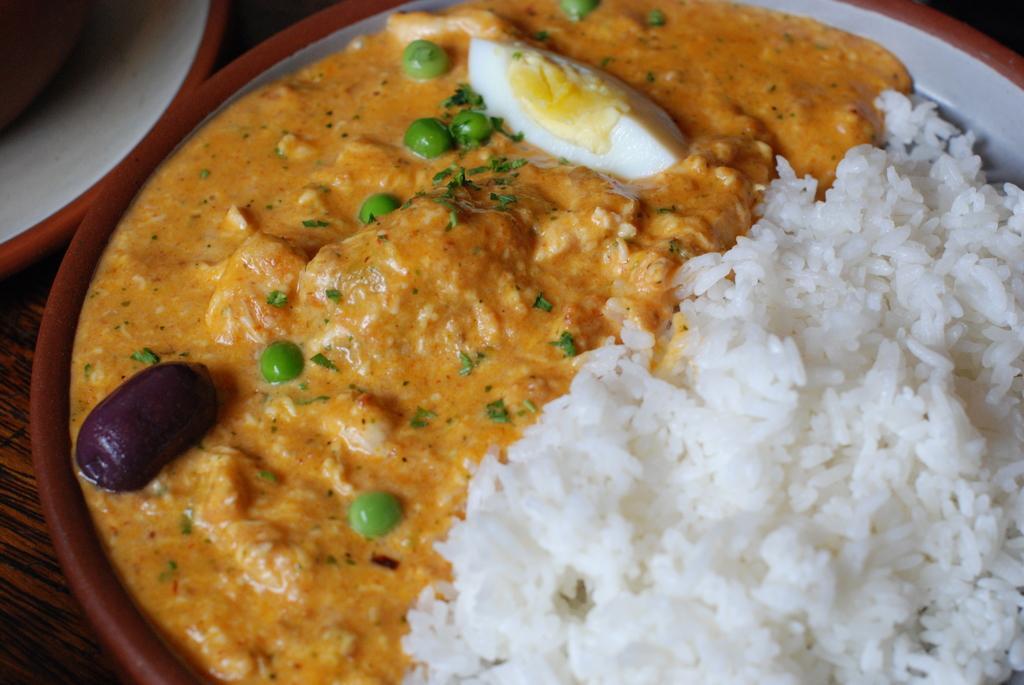Please provide a concise description of this image. In this picture we can see food in the plate. 